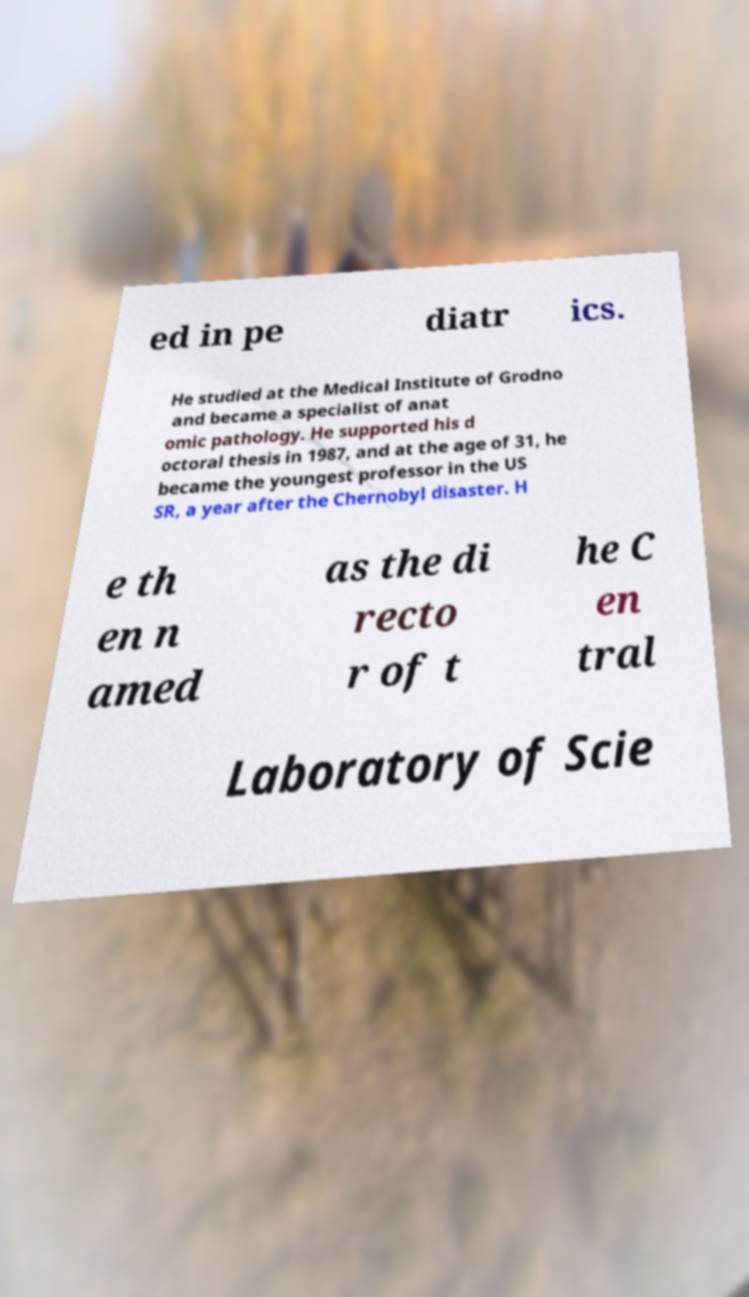I need the written content from this picture converted into text. Can you do that? ed in pe diatr ics. He studied at the Medical Institute of Grodno and became a specialist of anat omic pathology. He supported his d octoral thesis in 1987, and at the age of 31, he became the youngest professor in the US SR, a year after the Chernobyl disaster. H e th en n amed as the di recto r of t he C en tral Laboratory of Scie 